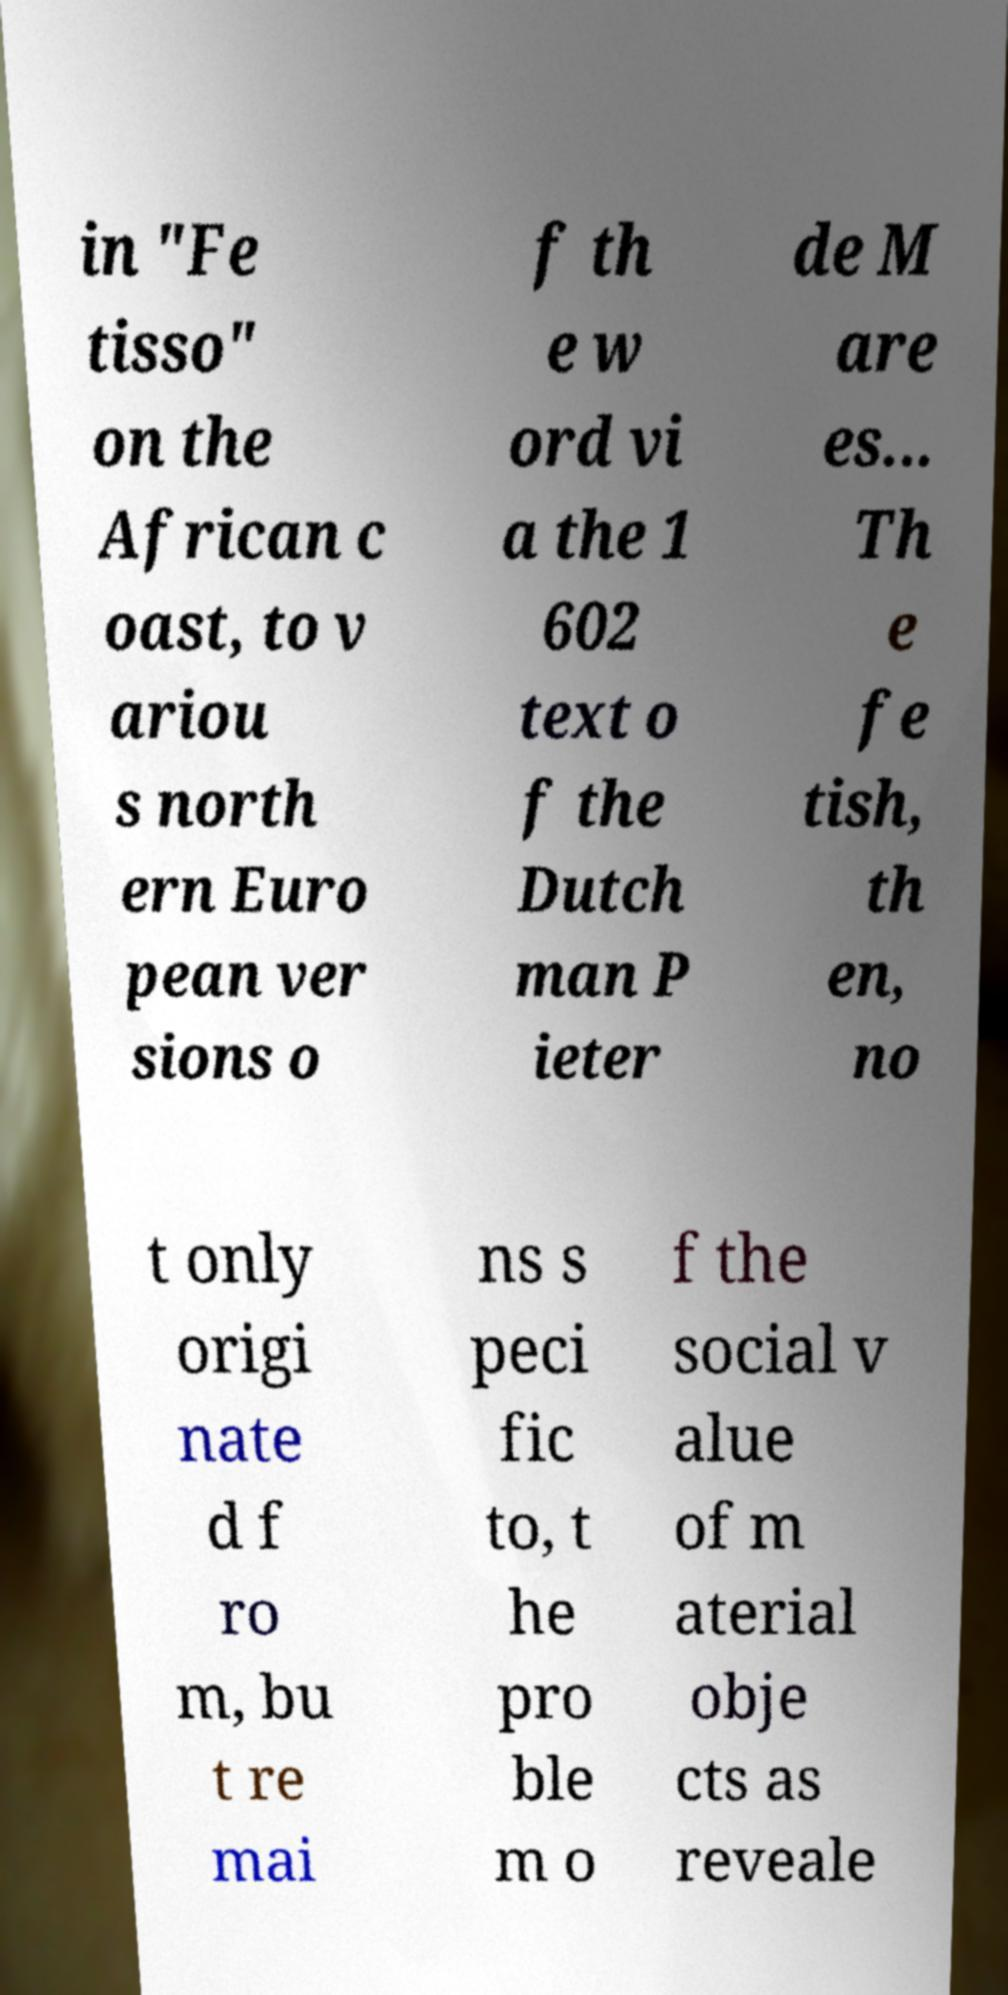Could you assist in decoding the text presented in this image and type it out clearly? in "Fe tisso" on the African c oast, to v ariou s north ern Euro pean ver sions o f th e w ord vi a the 1 602 text o f the Dutch man P ieter de M are es... Th e fe tish, th en, no t only origi nate d f ro m, bu t re mai ns s peci fic to, t he pro ble m o f the social v alue of m aterial obje cts as reveale 